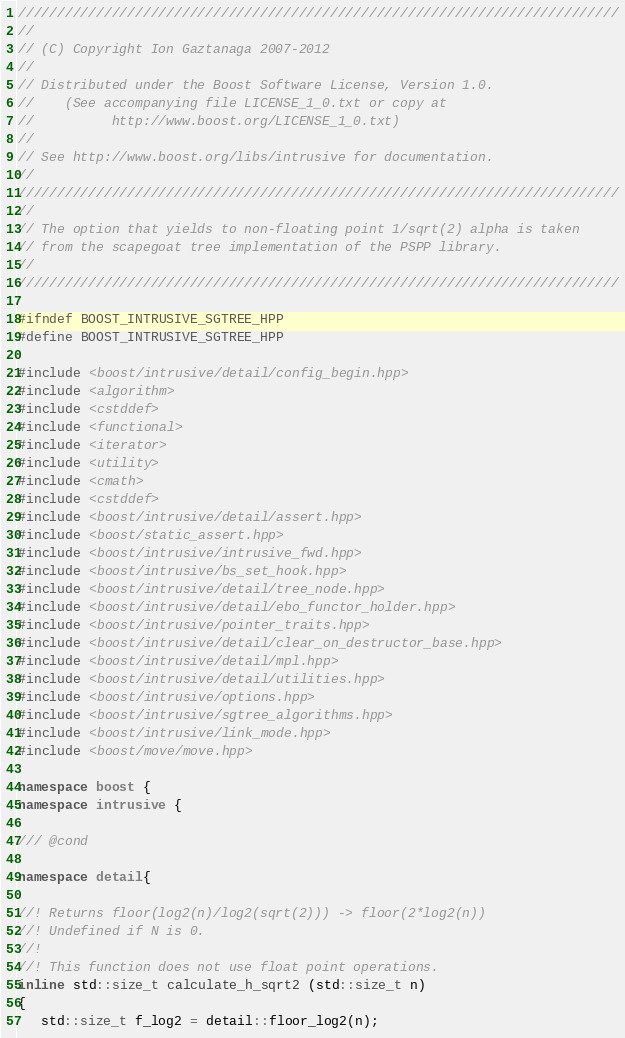<code> <loc_0><loc_0><loc_500><loc_500><_C++_>/////////////////////////////////////////////////////////////////////////////
//
// (C) Copyright Ion Gaztanaga 2007-2012
//
// Distributed under the Boost Software License, Version 1.0.
//    (See accompanying file LICENSE_1_0.txt or copy at
//          http://www.boost.org/LICENSE_1_0.txt)
//
// See http://www.boost.org/libs/intrusive for documentation.
//
/////////////////////////////////////////////////////////////////////////////
//
// The option that yields to non-floating point 1/sqrt(2) alpha is taken
// from the scapegoat tree implementation of the PSPP library.
//
/////////////////////////////////////////////////////////////////////////////

#ifndef BOOST_INTRUSIVE_SGTREE_HPP
#define BOOST_INTRUSIVE_SGTREE_HPP

#include <boost/intrusive/detail/config_begin.hpp>
#include <algorithm>
#include <cstddef>
#include <functional>
#include <iterator>
#include <utility>
#include <cmath>
#include <cstddef>
#include <boost/intrusive/detail/assert.hpp>
#include <boost/static_assert.hpp>
#include <boost/intrusive/intrusive_fwd.hpp>
#include <boost/intrusive/bs_set_hook.hpp>
#include <boost/intrusive/detail/tree_node.hpp>
#include <boost/intrusive/detail/ebo_functor_holder.hpp>
#include <boost/intrusive/pointer_traits.hpp>
#include <boost/intrusive/detail/clear_on_destructor_base.hpp>
#include <boost/intrusive/detail/mpl.hpp>
#include <boost/intrusive/detail/utilities.hpp>
#include <boost/intrusive/options.hpp>
#include <boost/intrusive/sgtree_algorithms.hpp>
#include <boost/intrusive/link_mode.hpp>
#include <boost/move/move.hpp>

namespace boost {
namespace intrusive {

/// @cond

namespace detail{

//! Returns floor(log2(n)/log2(sqrt(2))) -> floor(2*log2(n))
//! Undefined if N is 0.
//!
//! This function does not use float point operations.
inline std::size_t calculate_h_sqrt2 (std::size_t n)
{
   std::size_t f_log2 = detail::floor_log2(n);</code> 